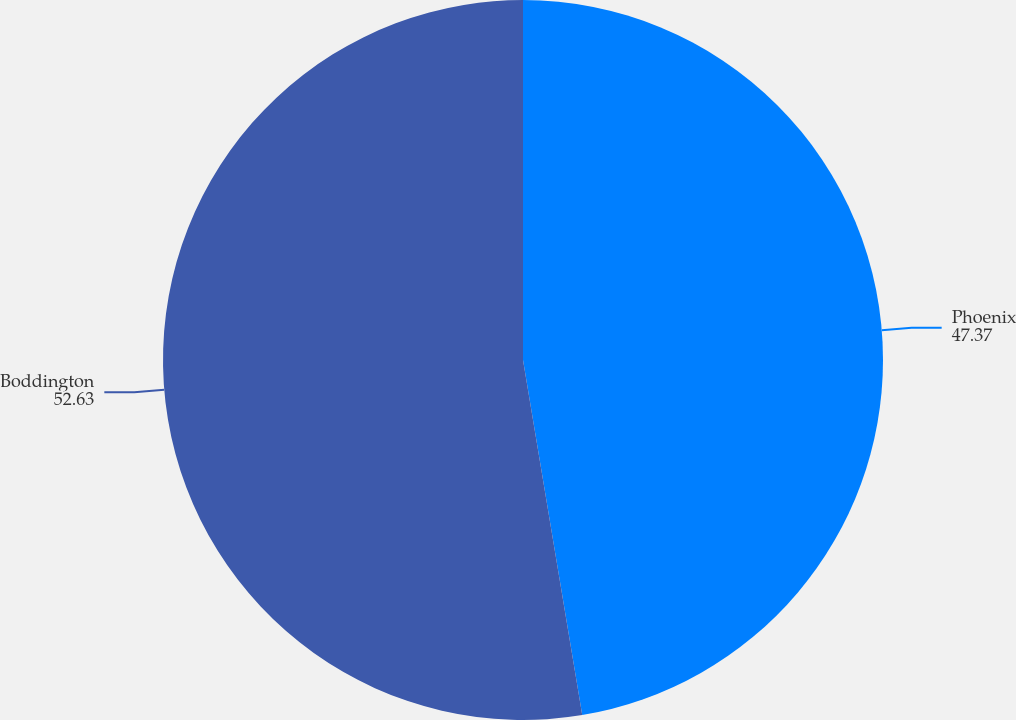<chart> <loc_0><loc_0><loc_500><loc_500><pie_chart><fcel>Phoenix<fcel>Boddington<nl><fcel>47.37%<fcel>52.63%<nl></chart> 